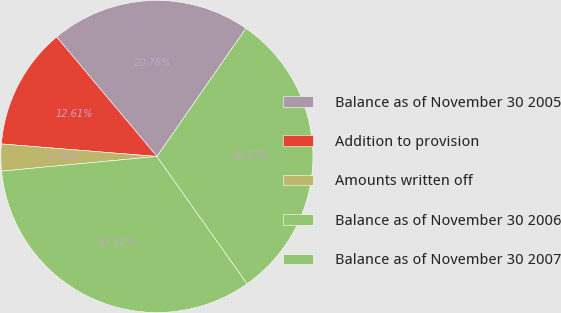<chart> <loc_0><loc_0><loc_500><loc_500><pie_chart><fcel>Balance as of November 30 2005<fcel>Addition to provision<fcel>Amounts written off<fcel>Balance as of November 30 2006<fcel>Balance as of November 30 2007<nl><fcel>20.78%<fcel>12.61%<fcel>2.78%<fcel>33.31%<fcel>30.53%<nl></chart> 